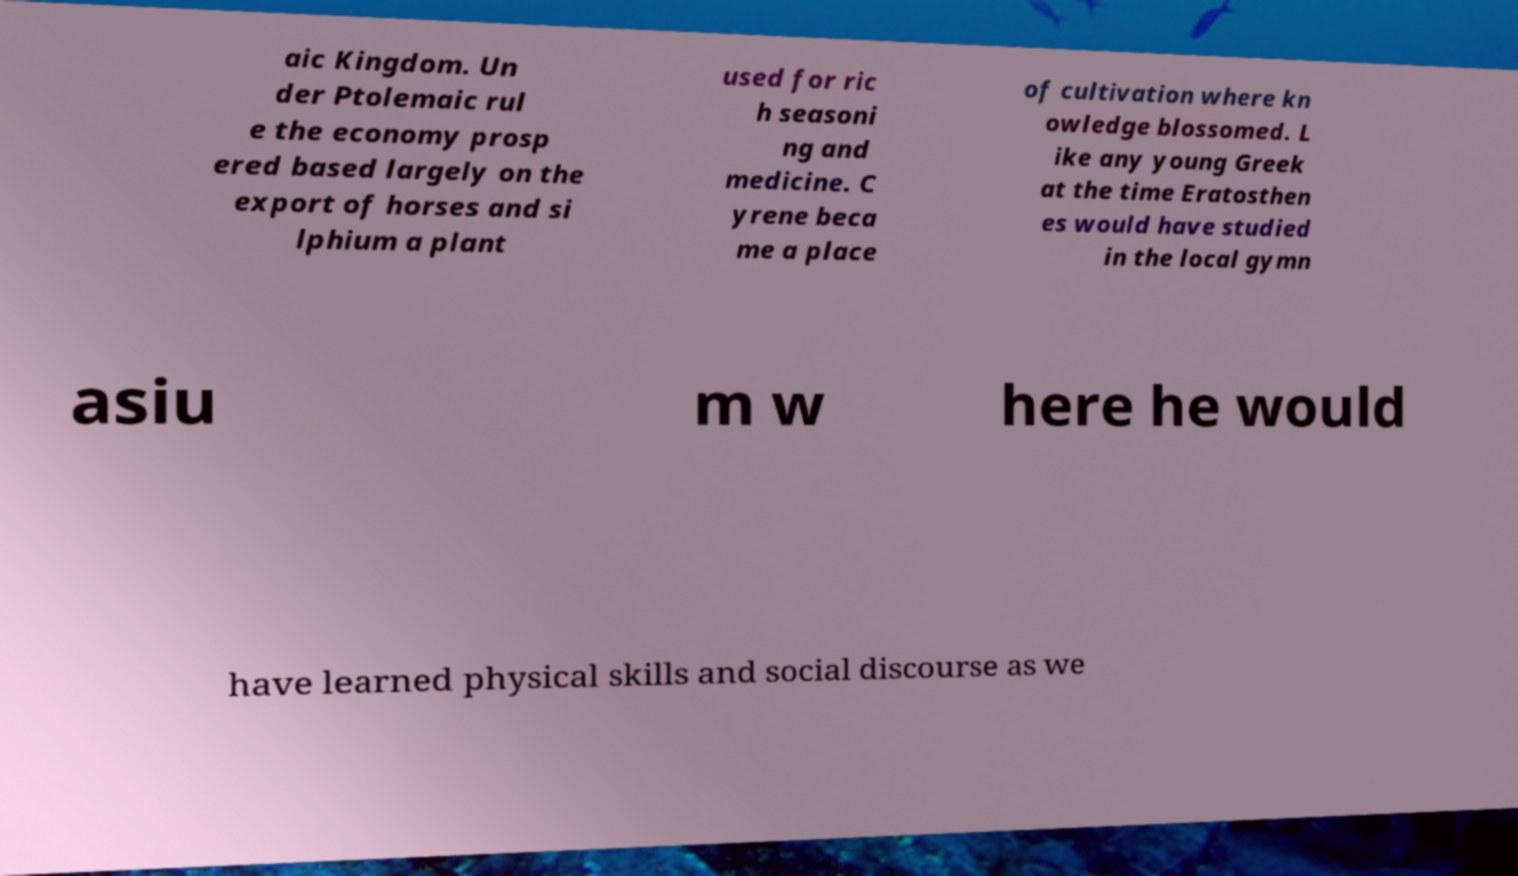There's text embedded in this image that I need extracted. Can you transcribe it verbatim? aic Kingdom. Un der Ptolemaic rul e the economy prosp ered based largely on the export of horses and si lphium a plant used for ric h seasoni ng and medicine. C yrene beca me a place of cultivation where kn owledge blossomed. L ike any young Greek at the time Eratosthen es would have studied in the local gymn asiu m w here he would have learned physical skills and social discourse as we 